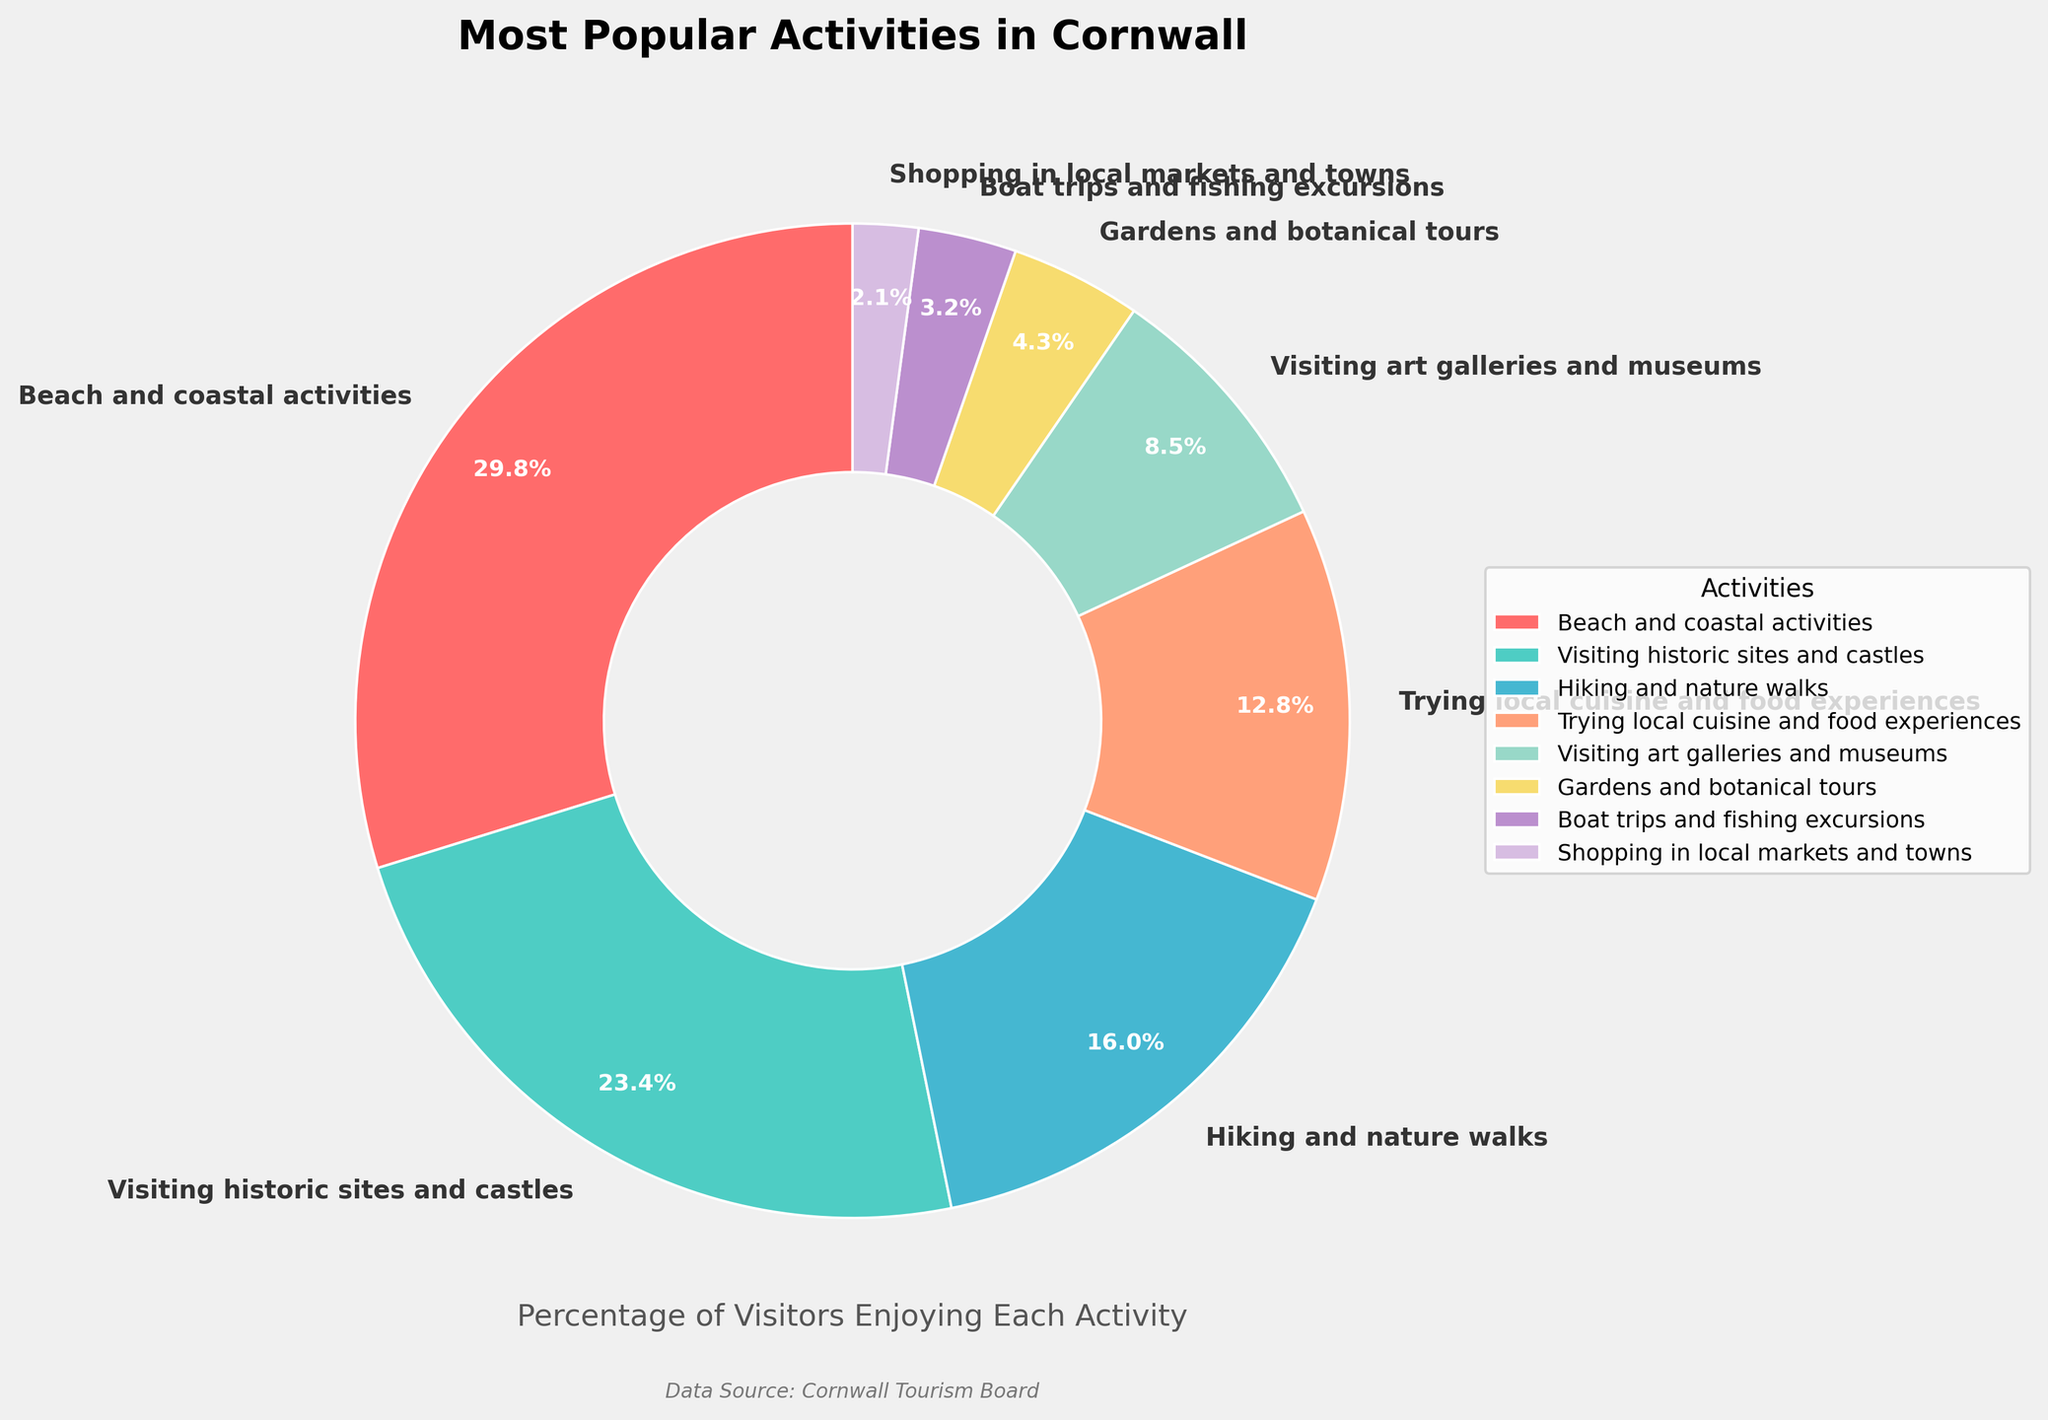Which activity is the most popular according to the pie chart? The most popular activity is represented by the largest section of the pie chart, which is labeled "Beach and coastal activities" with a percentage of 28%.
Answer: Beach and coastal activities Which activity has the smallest percentage of visitors' participation? The smallest section of the pie chart corresponds to "Shopping in local markets and towns", which has a percentage of 2%.
Answer: Shopping in local markets and towns How much more popular are Beach and coastal activities compared to Boat trips and fishing excursions? Subtract the percentage of Boat trips and fishing excursions (3%) from Beach and coastal activities (28%). This gives 28% - 3% = 25%.
Answer: 25% What is the combined percentage of visitors enjoying Beach and coastal activities, and Visiting historic sites and castles? Add the percentages of Beach and coastal activities (28%) and Visiting historic sites and castles (22%). This gives 28% + 22% = 50%.
Answer: 50% How does the popularity of Hiking and nature walks compare to that of Trying local cuisine and food experiences? The percentage for Hiking and nature walks is 15%, and for Trying local cuisine and food experiences, it is 12%. Therefore, Hiking and nature walks is more popular.
Answer: Hiking and nature walks is more popular Which activities have a percentage of visitors that is greater than 10% but less than 20%? Only Hiking and nature walks (15%) and Trying local cuisine and food experiences (12%) fall within this range.
Answer: Hiking and nature walks, Trying local cuisine and food experiences What percentage of visitors enjoy activities related to arts and culture (Visiting art galleries and museums)? The pie chart shows that Visiting art galleries and museums accounts for 8% of visitors' activities.
Answer: 8% If you combine the percentages of the least 4 popular activities, what fraction of the total percentage do they represent? Sum the percentages of the least 4 popular activities: Gardens and botanical tours (4%), Boat trips and fishing excursions (3%), Shopping in local markets and towns (2%), and Visiting art galleries and museums (8%), which gives 4% + 3% + 2% + 8% = 17%.
Answer: 17% Which activity is represented by the segment with a light green color? The segment with a light green color represents Visiting historic sites and castles with a percentage of 22%.
Answer: Visiting historic sites and castles 